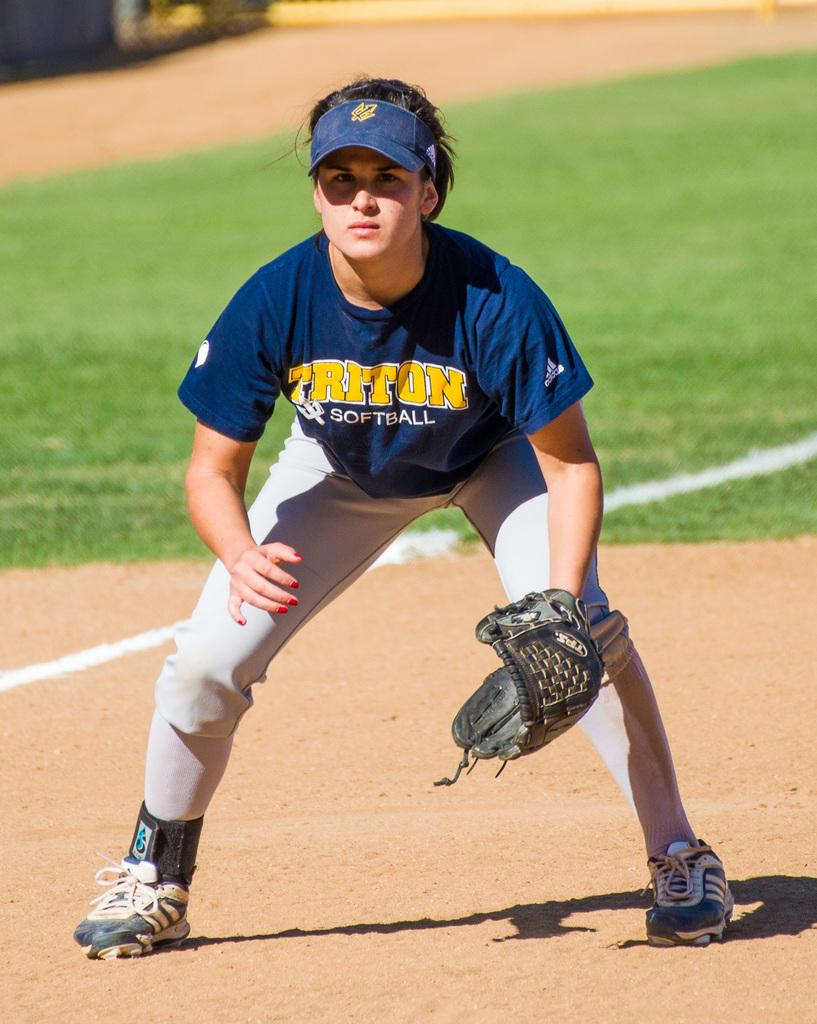<image>
Write a terse but informative summary of the picture. Baseball player for Triton getting ready to catch a ball. 